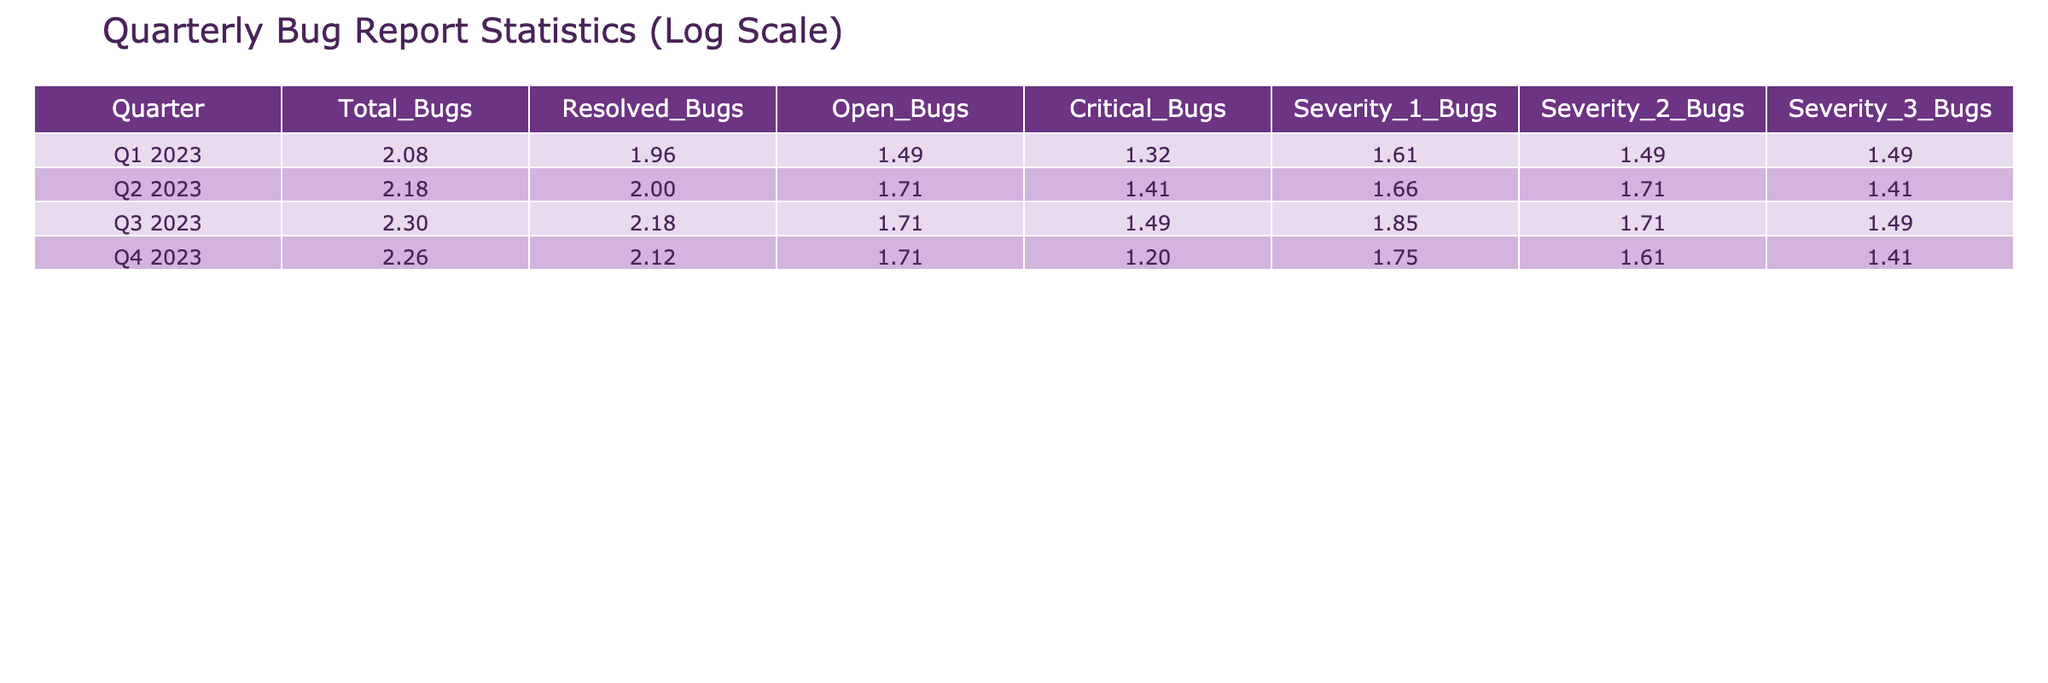What is the total number of bugs reported in Q2 2023? From the table, we look at the column "Total_Bugs" for Q2 2023, which lists the value 150.
Answer: 150 How many bugs were resolved in Q1 2023? Looking at the column "Resolved_Bugs" for Q1 2023, the table indicates there were 90 resolved bugs.
Answer: 90 Is there a higher number of critical bugs in Q3 2023 compared to Q4 2023? In Q3 2023, the number of critical bugs is 30, while in Q4 2023 it is 15. Since 30 is greater than 15, the answer is yes.
Answer: Yes What is the total number of open bugs across all quarters? To find the total open bugs, we sum the "Open_Bugs" values: 30 (Q1) + 50 (Q2) + 50 (Q3) + 50 (Q4) = 180.
Answer: 180 What percentage of total bugs in Q1 2023 were resolved? To calculate the percentage, divide the resolved bugs (90) by total bugs (120) and multiply by 100: (90/120) * 100 = 75%.
Answer: 75% In which quarter were the least critical bugs recorded? By comparing the "Critical_Bugs" values: Q1 has 20, Q2 has 25, Q3 has 30, and Q4 has 15. The least amount is 15 in Q4 2023.
Answer: Q4 2023 How many severity 1 bugs were reported in Q3 2023? Referring to the table, the "Severity_1_Bugs" column for Q3 2023 shows there were 70 severity 1 bugs.
Answer: 70 What is the average number of open bugs per quarter? We have 4 quarters with open bugs of 30, 50, 50, and 50. The total is 180, so the average is 180/4 = 45.
Answer: 45 Is the total number of bugs in Q3 2023 greater than the total in Q2 2023? The total bugs in Q3 2023 is 200 and in Q2 2023 is 150. Since 200 is greater than 150, the answer is yes.
Answer: Yes 